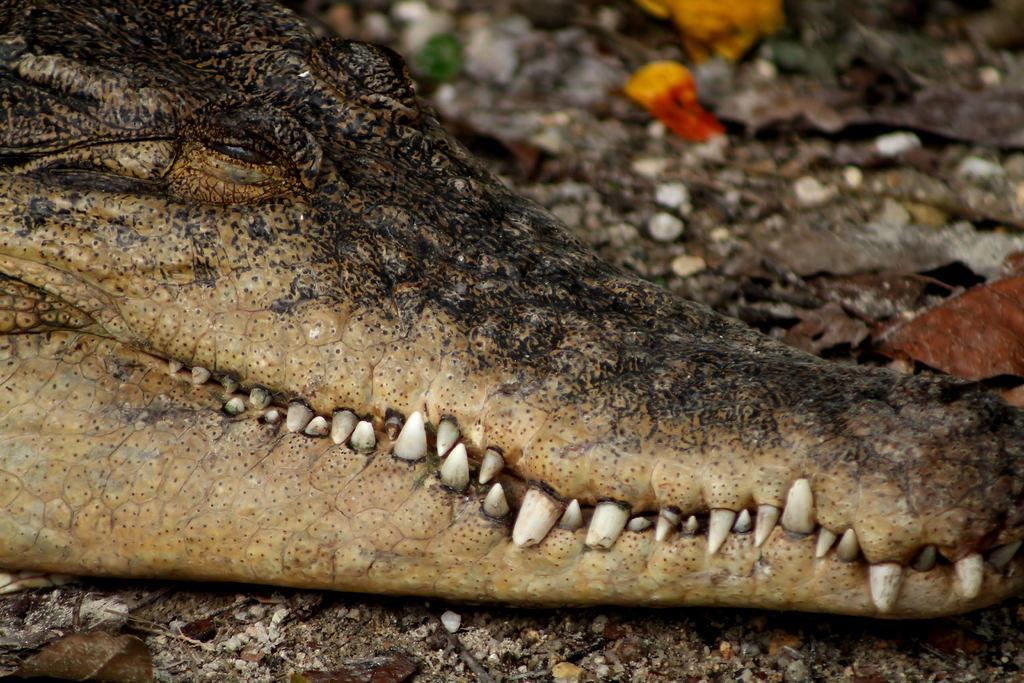What type of animal is in the image? There is a crocodile in the image. Where is the crocodile located in the image? The crocodile is on the land. What type of bat can be seen carrying a sack in the image? There is no bat or sack present in the image; it features a crocodile on the land. 